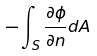<formula> <loc_0><loc_0><loc_500><loc_500>- \int _ { S } \frac { \partial \phi } { \partial n } d A</formula> 